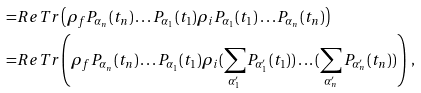Convert formula to latex. <formula><loc_0><loc_0><loc_500><loc_500>= & R e T r \left ( \rho _ { f } P _ { \alpha _ { n } } ( t _ { n } ) \dots P _ { \alpha _ { 1 } } ( t _ { 1 } ) \rho _ { i } P _ { \alpha _ { 1 } } ( t _ { 1 } ) \dots P _ { \alpha _ { n } } ( t _ { n } ) \right ) \\ = & R e T r \left ( \rho _ { f } P _ { \alpha _ { n } } ( t _ { n } ) \dots P _ { \alpha _ { 1 } } ( t _ { 1 } ) \rho _ { i } ( \sum _ { \alpha ^ { \prime } _ { 1 } } P _ { \alpha ^ { \prime } _ { 1 } } ( t _ { 1 } ) ) \dots ( \sum _ { \alpha ^ { \prime } _ { n } } P _ { \alpha ^ { \prime } _ { n } } ( t _ { n } ) ) \right ) \ ,</formula> 